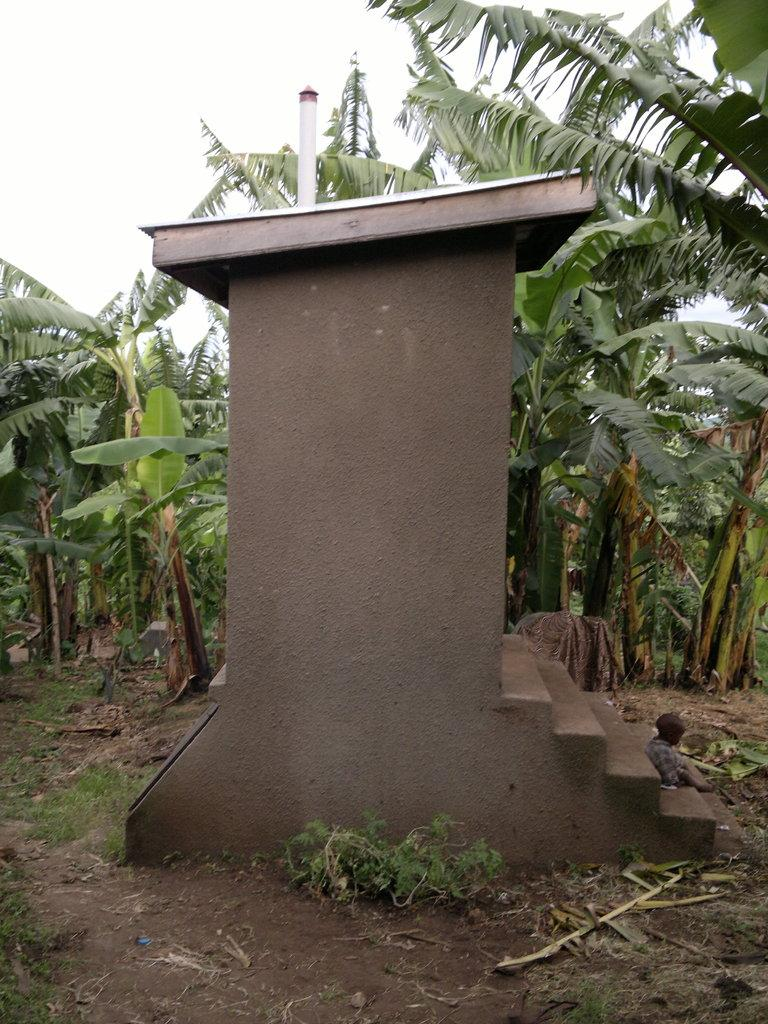What is the main subject of the image? The main subject of the image is a construction. What can be seen in the background of the image? The construction is in front of a banana field. What is the surrounding area like? There is plain mud land around the construction. How many socks are hanging on the construction in the image? There are no socks present in the image; it features a construction in front of a banana field with plain mud land surrounding it. 